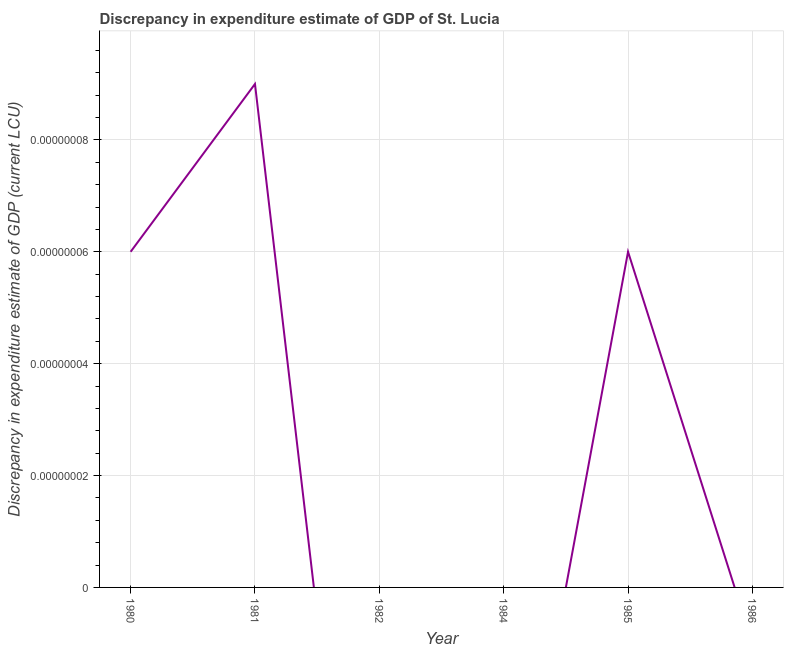What is the discrepancy in expenditure estimate of gdp in 1980?
Your answer should be compact. 6e-8. Across all years, what is the maximum discrepancy in expenditure estimate of gdp?
Provide a short and direct response. 9e-8. In which year was the discrepancy in expenditure estimate of gdp maximum?
Your response must be concise. 1981. What is the sum of the discrepancy in expenditure estimate of gdp?
Ensure brevity in your answer.  2.1e-7. What is the difference between the discrepancy in expenditure estimate of gdp in 1981 and 1985?
Your answer should be compact. 3.0000000000000004e-8. What is the average discrepancy in expenditure estimate of gdp per year?
Provide a succinct answer. 3.5e-8. What is the median discrepancy in expenditure estimate of gdp?
Offer a very short reply. 3e-8. In how many years, is the discrepancy in expenditure estimate of gdp greater than 9.2e-08 LCU?
Provide a succinct answer. 0. Is the discrepancy in expenditure estimate of gdp in 1981 less than that in 1985?
Your answer should be compact. No. What is the difference between the highest and the second highest discrepancy in expenditure estimate of gdp?
Provide a succinct answer. 3.0000000000000004e-8. Is the sum of the discrepancy in expenditure estimate of gdp in 1980 and 1981 greater than the maximum discrepancy in expenditure estimate of gdp across all years?
Ensure brevity in your answer.  Yes. What is the difference between the highest and the lowest discrepancy in expenditure estimate of gdp?
Provide a short and direct response. 9e-8. In how many years, is the discrepancy in expenditure estimate of gdp greater than the average discrepancy in expenditure estimate of gdp taken over all years?
Offer a very short reply. 3. How many lines are there?
Ensure brevity in your answer.  1. What is the difference between two consecutive major ticks on the Y-axis?
Ensure brevity in your answer.  2e-8. Does the graph contain any zero values?
Your response must be concise. Yes. What is the title of the graph?
Ensure brevity in your answer.  Discrepancy in expenditure estimate of GDP of St. Lucia. What is the label or title of the X-axis?
Your answer should be compact. Year. What is the label or title of the Y-axis?
Offer a very short reply. Discrepancy in expenditure estimate of GDP (current LCU). What is the Discrepancy in expenditure estimate of GDP (current LCU) of 1980?
Offer a very short reply. 6e-8. What is the Discrepancy in expenditure estimate of GDP (current LCU) of 1981?
Your answer should be very brief. 9e-8. What is the Discrepancy in expenditure estimate of GDP (current LCU) in 1984?
Keep it short and to the point. 0. What is the Discrepancy in expenditure estimate of GDP (current LCU) in 1985?
Offer a terse response. 6e-8. What is the Discrepancy in expenditure estimate of GDP (current LCU) of 1986?
Your answer should be very brief. 0. What is the difference between the Discrepancy in expenditure estimate of GDP (current LCU) in 1980 and 1981?
Your answer should be very brief. -0. What is the difference between the Discrepancy in expenditure estimate of GDP (current LCU) in 1981 and 1985?
Offer a very short reply. 0. What is the ratio of the Discrepancy in expenditure estimate of GDP (current LCU) in 1980 to that in 1981?
Provide a short and direct response. 0.67. What is the ratio of the Discrepancy in expenditure estimate of GDP (current LCU) in 1980 to that in 1985?
Keep it short and to the point. 1. What is the ratio of the Discrepancy in expenditure estimate of GDP (current LCU) in 1981 to that in 1985?
Offer a terse response. 1.5. 